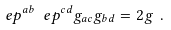Convert formula to latex. <formula><loc_0><loc_0><loc_500><loc_500>\ e p ^ { a b } \ e p ^ { c d } g _ { a c } g _ { b d } = 2 g \ .</formula> 